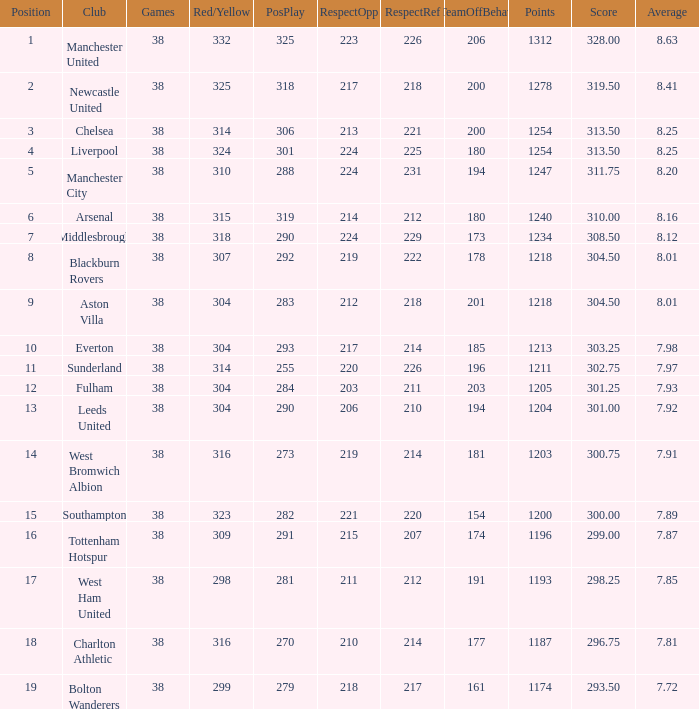Name the pos for west ham united 17.0. 